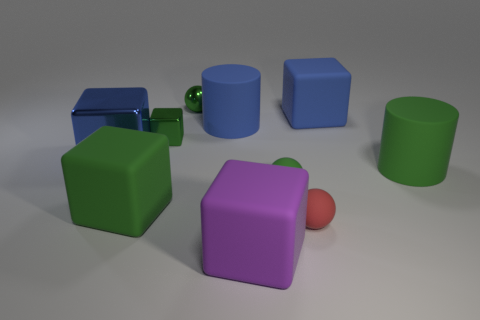Subtract 1 blocks. How many blocks are left? 4 Subtract all purple blocks. How many blocks are left? 4 Subtract all blue rubber blocks. How many blocks are left? 4 Subtract all gray cubes. Subtract all gray cylinders. How many cubes are left? 5 Subtract all cylinders. How many objects are left? 8 Add 6 tiny red metal spheres. How many tiny red metal spheres exist? 6 Subtract 2 green spheres. How many objects are left? 8 Subtract all small rubber spheres. Subtract all small green objects. How many objects are left? 5 Add 1 tiny red matte objects. How many tiny red matte objects are left? 2 